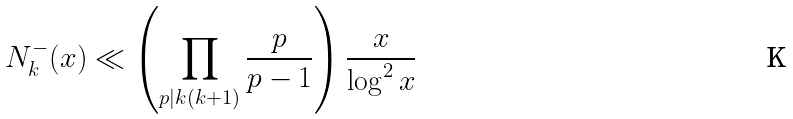<formula> <loc_0><loc_0><loc_500><loc_500>N _ { k } ^ { - } ( x ) \ll \left ( \prod _ { p | k ( k + 1 ) } \frac { p } { p - 1 } \right ) \frac { x } { \log ^ { 2 } x }</formula> 